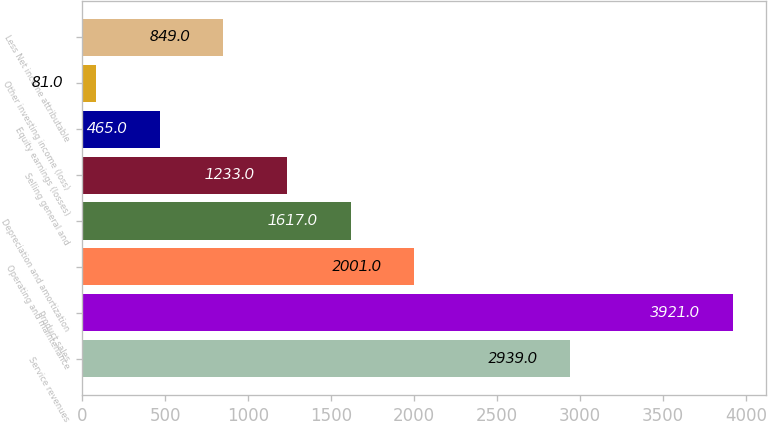Convert chart. <chart><loc_0><loc_0><loc_500><loc_500><bar_chart><fcel>Service revenues<fcel>Product sales<fcel>Operating and maintenance<fcel>Depreciation and amortization<fcel>Selling general and<fcel>Equity earnings (losses)<fcel>Other investing income (loss)<fcel>Less Net income attributable<nl><fcel>2939<fcel>3921<fcel>2001<fcel>1617<fcel>1233<fcel>465<fcel>81<fcel>849<nl></chart> 